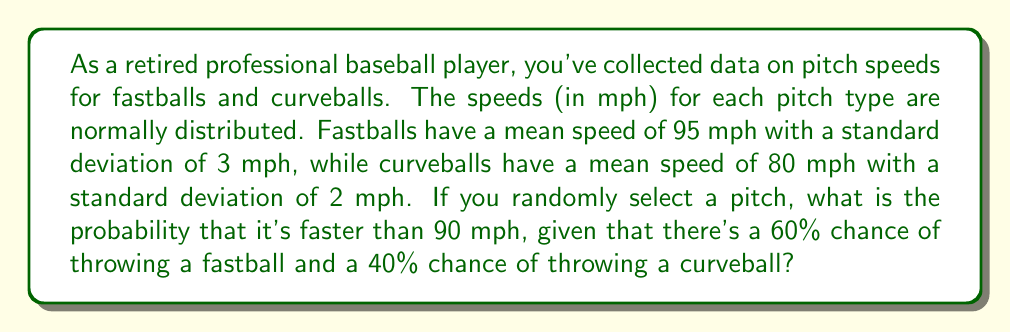Could you help me with this problem? Let's approach this step-by-step:

1) Let F be the event of throwing a fastball, and C be the event of throwing a curveball.
   P(F) = 0.60, P(C) = 0.40

2) Let X be the speed of the pitch. We need to find P(X > 90).

3) We can use the law of total probability:
   P(X > 90) = P(X > 90|F) * P(F) + P(X > 90|C) * P(C)

4) For the fastball:
   X|F ~ N(μ=95, σ=3)
   Z = (90 - 95) / 3 = -1.67
   P(X > 90|F) = 1 - Φ(-1.67) = Φ(1.67) ≈ 0.9525

5) For the curveball:
   X|C ~ N(μ=80, σ=2)
   Z = (90 - 80) / 2 = 5
   P(X > 90|C) = 1 - Φ(5) ≈ 0

6) Now we can plug these values into our total probability formula:

   P(X > 90) = 0.9525 * 0.60 + 0 * 0.40

7) Calculating:
   P(X > 90) = 0.5715

Therefore, the probability that a randomly selected pitch is faster than 90 mph is approximately 0.5715 or 57.15%.
Answer: 0.5715 